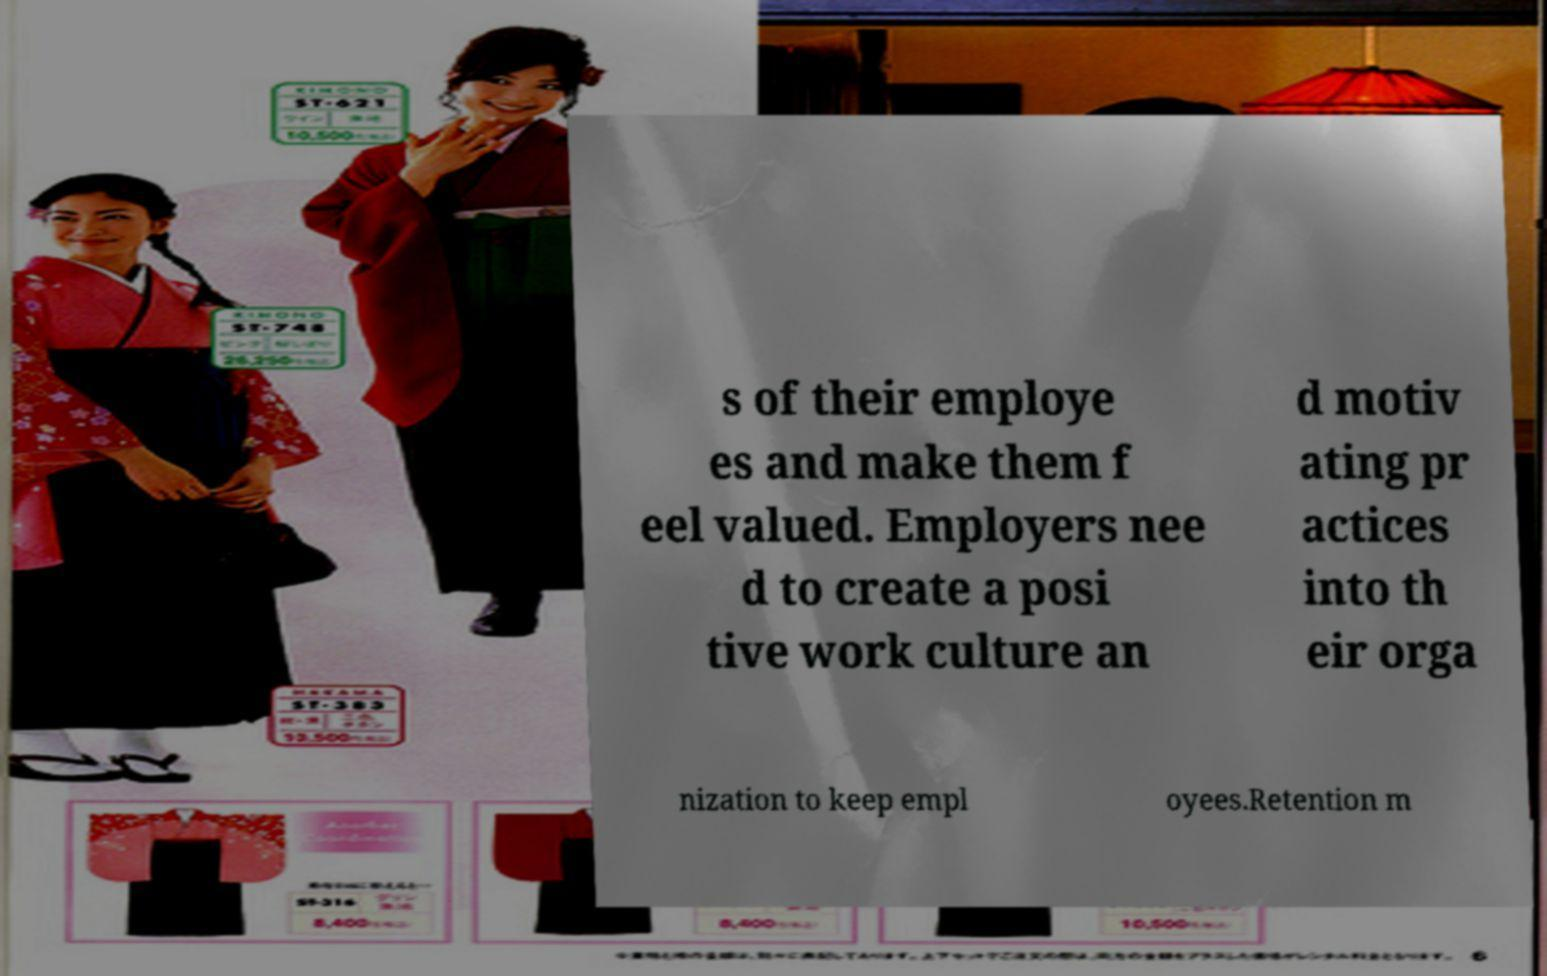For documentation purposes, I need the text within this image transcribed. Could you provide that? s of their employe es and make them f eel valued. Employers nee d to create a posi tive work culture an d motiv ating pr actices into th eir orga nization to keep empl oyees.Retention m 